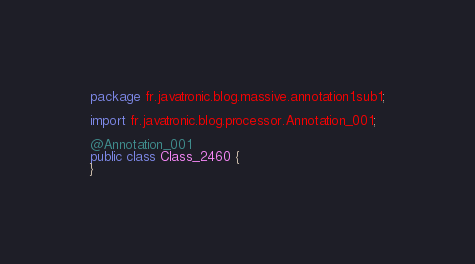Convert code to text. <code><loc_0><loc_0><loc_500><loc_500><_Java_>package fr.javatronic.blog.massive.annotation1.sub1;

import fr.javatronic.blog.processor.Annotation_001;

@Annotation_001
public class Class_2460 {
}
</code> 